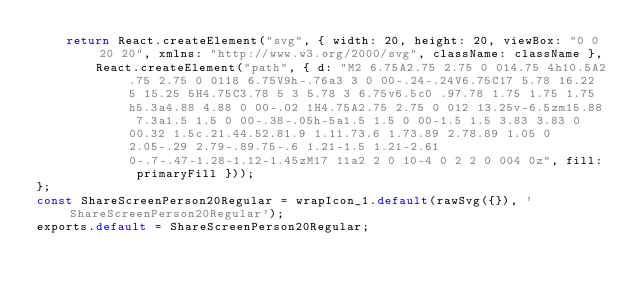<code> <loc_0><loc_0><loc_500><loc_500><_JavaScript_>    return React.createElement("svg", { width: 20, height: 20, viewBox: "0 0 20 20", xmlns: "http://www.w3.org/2000/svg", className: className },
        React.createElement("path", { d: "M2 6.75A2.75 2.75 0 014.75 4h10.5A2.75 2.75 0 0118 6.75V9h-.76a3 3 0 00-.24-.24V6.75C17 5.78 16.22 5 15.25 5H4.75C3.78 5 3 5.78 3 6.75v6.5c0 .97.78 1.75 1.75 1.75h5.3a4.88 4.88 0 00-.02 1H4.75A2.75 2.75 0 012 13.25v-6.5zm15.88 7.3a1.5 1.5 0 00-.38-.05h-5a1.5 1.5 0 00-1.5 1.5 3.83 3.83 0 00.32 1.5c.21.44.52.81.9 1.11.73.6 1.73.89 2.78.89 1.05 0 2.05-.29 2.79-.89.75-.6 1.21-1.5 1.21-2.61 0-.7-.47-1.28-1.12-1.45zM17 11a2 2 0 10-4 0 2 2 0 004 0z", fill: primaryFill }));
};
const ShareScreenPerson20Regular = wrapIcon_1.default(rawSvg({}), 'ShareScreenPerson20Regular');
exports.default = ShareScreenPerson20Regular;
</code> 